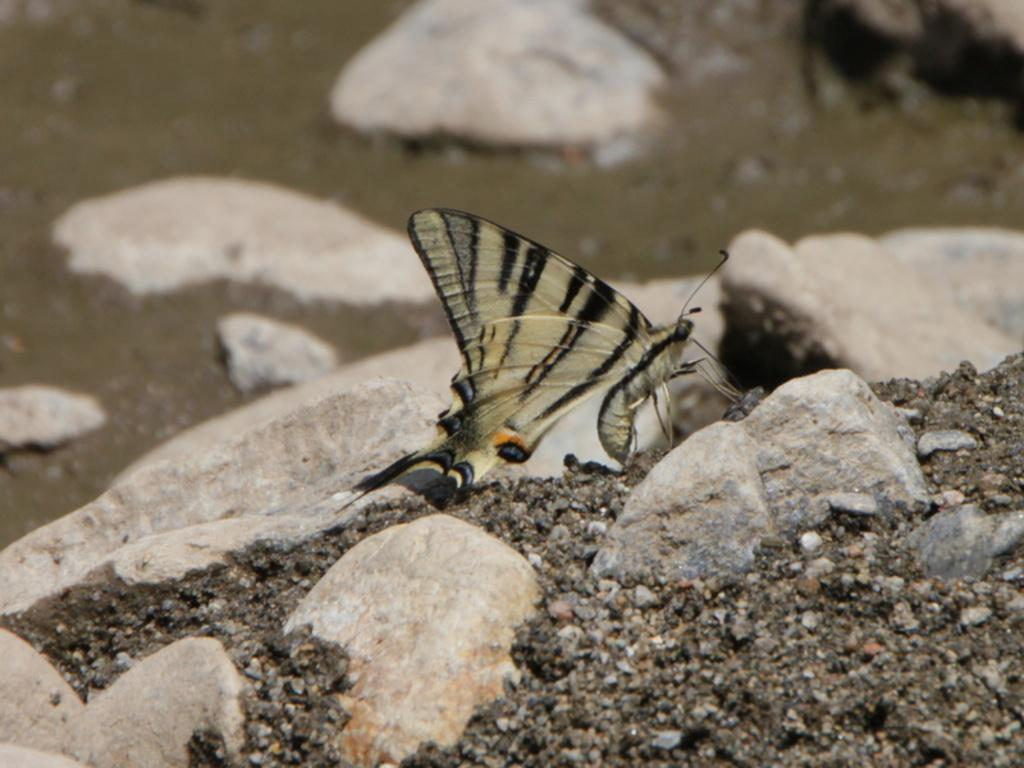What is the main subject of the image? The main subject of the image is a butterfly. Can you describe the colors of the butterfly? The butterfly has cream, black, grey, and orange colors. Where is the butterfly located in the image? The butterfly is on a rock. What else can be seen in the image besides the butterfly? There are rocks and the ground visible in the image. Can you tell me how many hens are present in the image? There are no hens present in the image; it features a butterfly on a rock. What type of whip is being used by the butterfly in the image? There is no whip present in the image, and butterflies do not use whips. 